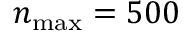Convert formula to latex. <formula><loc_0><loc_0><loc_500><loc_500>n _ { \max } = 5 0 0</formula> 